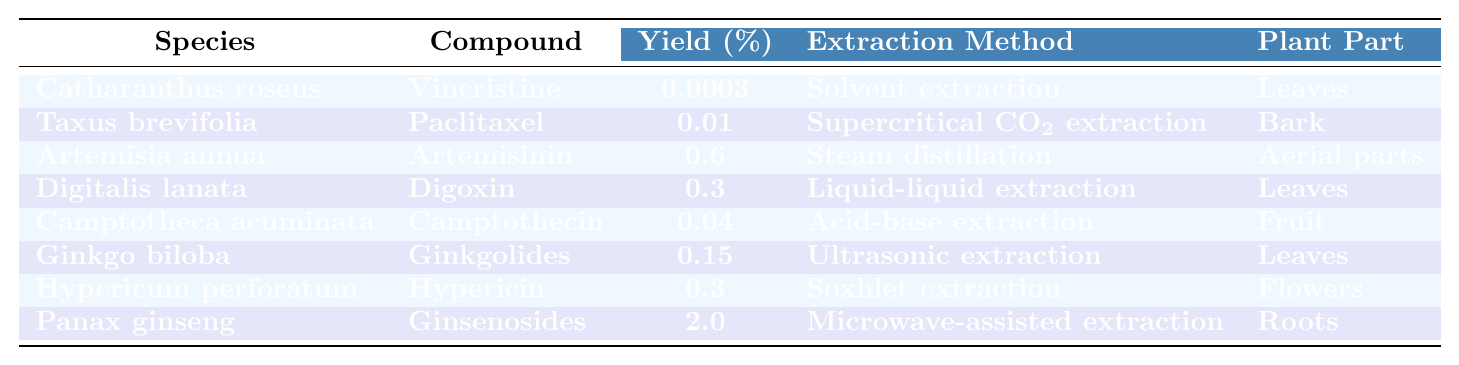What is the yield of Ginsenosides from Panax ginseng? The table indicates that the yield of Ginsenosides from Panax ginseng is listed as 2.0%.
Answer: 2.0% Which extraction method is used for Camptothecin? According to the table, Camptothecin is extracted using acid-base extraction.
Answer: Acid-base extraction What is the compound with the highest yield? By examining the yields listed, Ginsenosides from Panax ginseng has the highest yield at 2.0%.
Answer: Ginsenosides Is the yield of Hypericin greater than that of Vincristine? The yield of Hypericin is 0.3%, and the yield of Vincristine is 0.0003%. Since 0.3% is greater than 0.0003%, the statement is true.
Answer: Yes What is the average yield of compounds extracted from leaves? The yields from leaves are 0.0003% (Vincristine) for Catharanthus roseus, 0.3% (Digoxin) for Digitalis lanata, and 0.15% (Ginkgolides) for Ginkgo biloba. The average yield is (0.0003 + 0.3 + 0.15) / 3 = 0.1501%.
Answer: 0.1501% Which plant part used for extraction corresponds to the highest yield? The only plant part that corresponds to the highest yield (2.0%) from Panax ginseng, which is the roots.
Answer: Roots What are the extraction methods for Artemisinin and Ginsenosides? The extraction method for Artemisinin from Artemisia annua is steam distillation, and for Ginsenosides from Panax ginseng, it is microwave-assisted extraction.
Answer: Steam distillation; Microwave-assisted extraction Is there a compound extracted from flowers? Yes, Hypericin is extracted from flowers.
Answer: Yes If we combine the yields of all compounds extracted using solvent methods, what would that total be? The only solvent method used is for Vincristine (0.0003%) from Catharanthus roseus; therefore, the total yield is simply 0.0003%.
Answer: 0.0003% What species provides the compound Paclitaxel, and what part of the plant is used? The species providing Paclitaxel is Taxus brevifolia, and the part of the plant used is bark.
Answer: Taxus brevifolia; Bark 